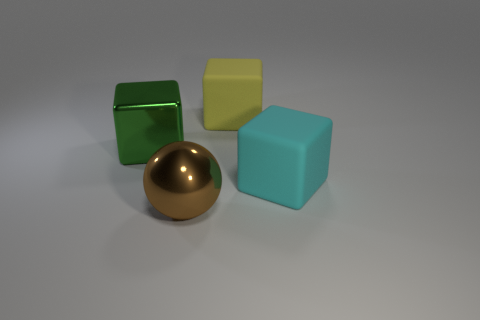Subtract all brown blocks. Subtract all purple balls. How many blocks are left? 3 Add 3 big metal objects. How many objects exist? 7 Subtract all balls. How many objects are left? 3 Add 2 metallic things. How many metallic things are left? 4 Add 1 large green objects. How many large green objects exist? 2 Subtract 0 green spheres. How many objects are left? 4 Subtract all big cyan metallic spheres. Subtract all green objects. How many objects are left? 3 